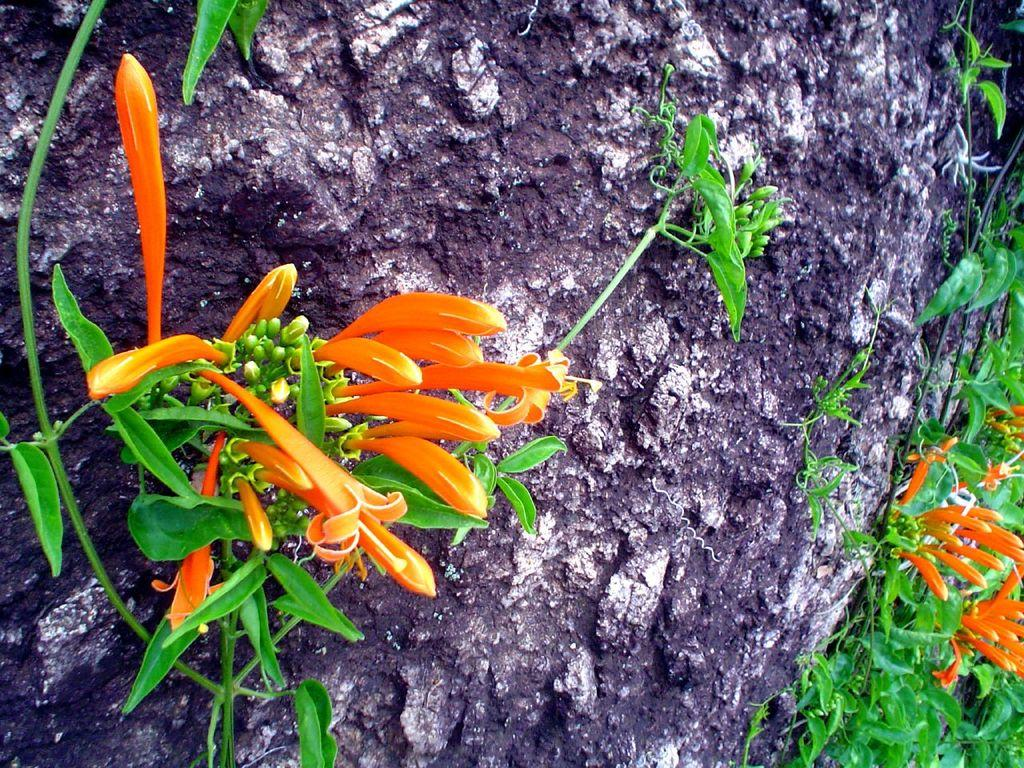What is the main object in the image? There is a stone in the image. What is growing on the stone? There is a creeper on the stone. Can you describe the creeper? The creeper has a stem, leaves, flowers, and buds. What type of knot can be seen in the creeper in the image? There is no knot present in the creeper in the image. What purpose does the creeper serve in the image? The image does not provide information about the purpose of the creeper. 